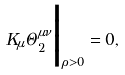<formula> <loc_0><loc_0><loc_500><loc_500>K _ { \mu } \Theta _ { 2 } ^ { \mu \nu } { \Big | } _ { \rho > 0 } = 0 ,</formula> 